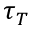<formula> <loc_0><loc_0><loc_500><loc_500>\tau _ { T }</formula> 